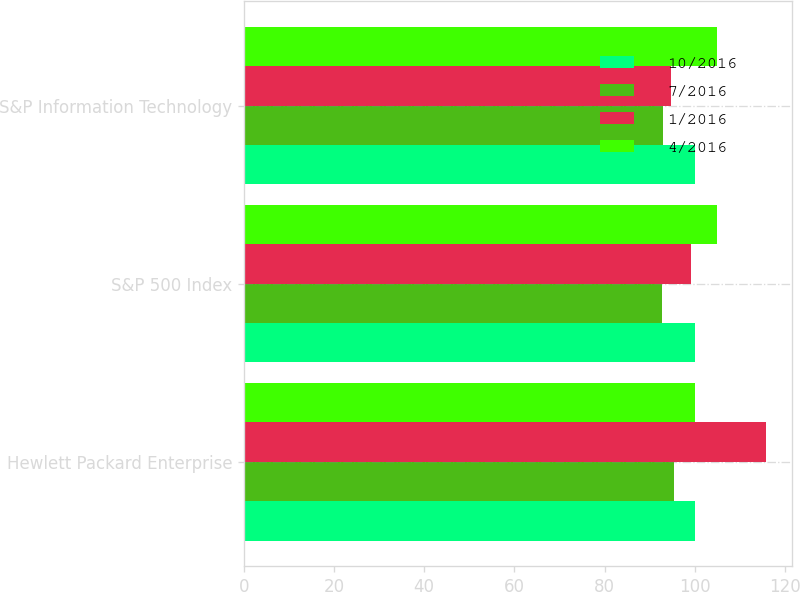<chart> <loc_0><loc_0><loc_500><loc_500><stacked_bar_chart><ecel><fcel>Hewlett Packard Enterprise<fcel>S&P 500 Index<fcel>S&P Information Technology<nl><fcel>10/2016<fcel>100<fcel>100<fcel>100<nl><fcel>7/2016<fcel>95.3<fcel>92.71<fcel>92.88<nl><fcel>1/2016<fcel>115.78<fcel>99.25<fcel>94.74<nl><fcel>4/2016<fcel>100<fcel>105.02<fcel>104.96<nl></chart> 